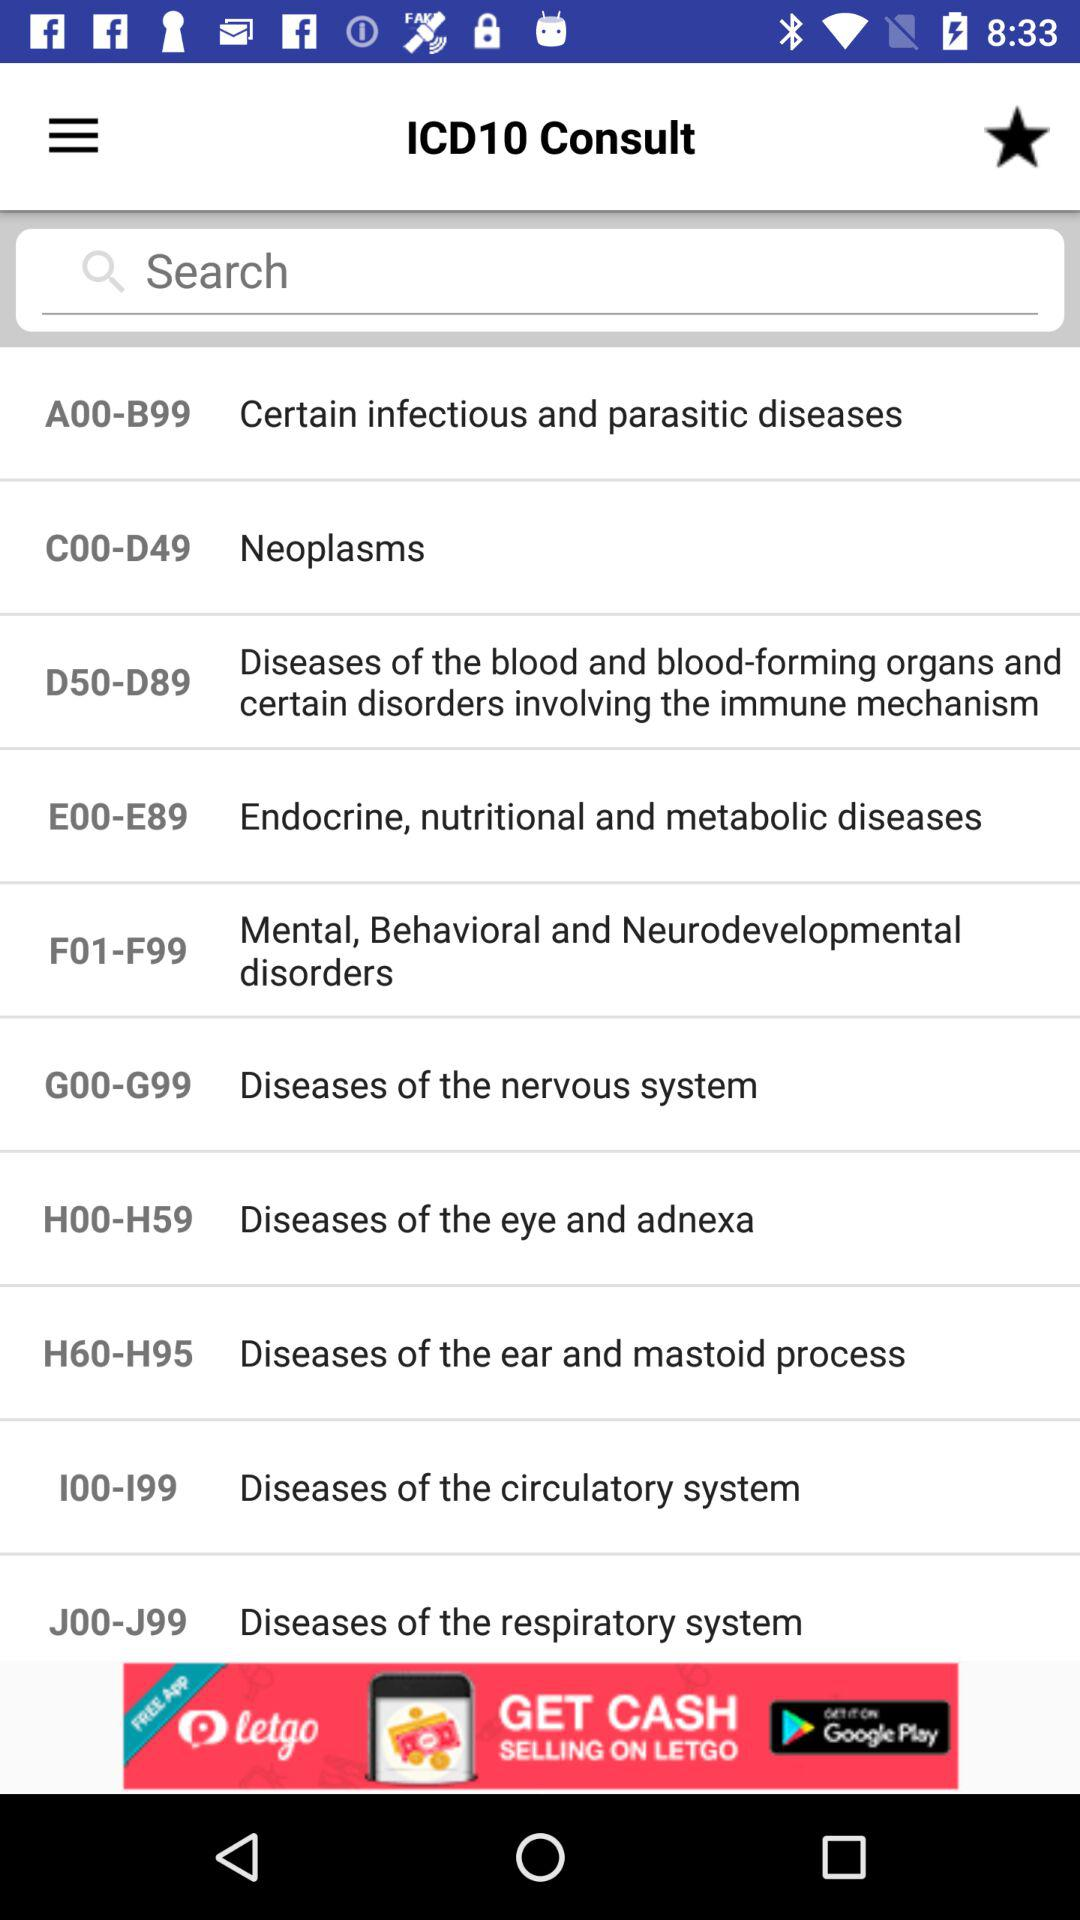What is the code for "Certain infectious and parasitic diseases"? The code for "Certain infectious and parasitic diseases" is "A00-B99". 